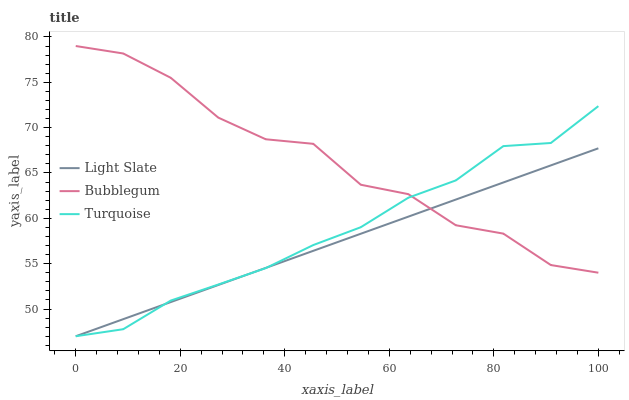Does Turquoise have the minimum area under the curve?
Answer yes or no. No. Does Turquoise have the maximum area under the curve?
Answer yes or no. No. Is Turquoise the smoothest?
Answer yes or no. No. Is Turquoise the roughest?
Answer yes or no. No. Does Bubblegum have the lowest value?
Answer yes or no. No. Does Turquoise have the highest value?
Answer yes or no. No. 